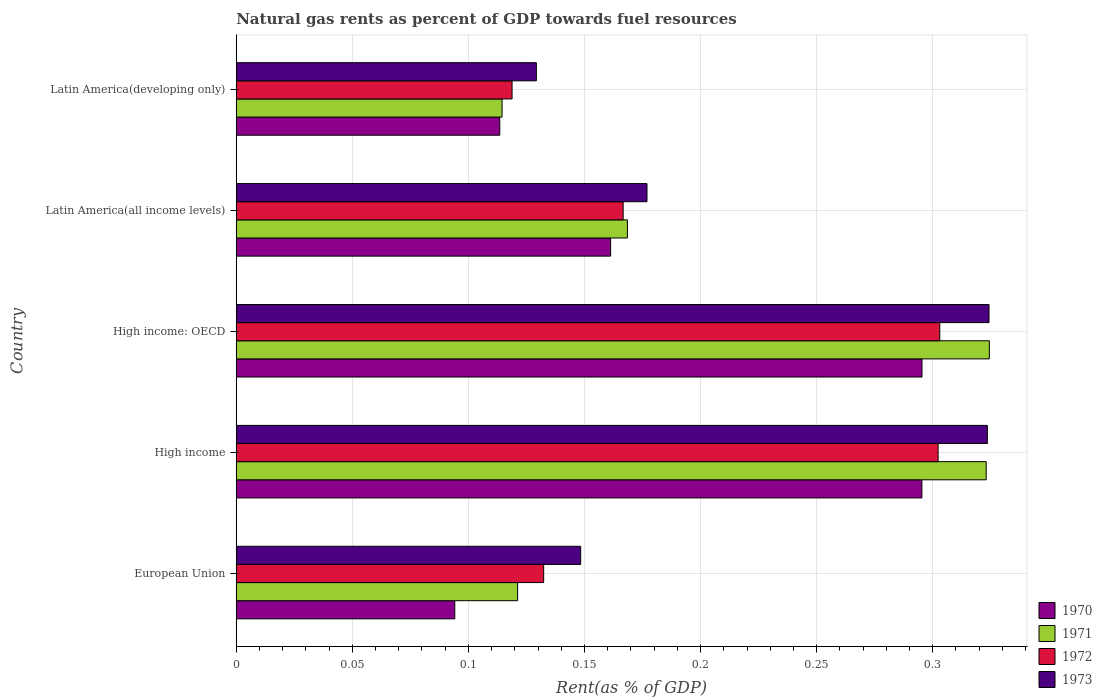How many different coloured bars are there?
Your answer should be very brief. 4. Are the number of bars per tick equal to the number of legend labels?
Keep it short and to the point. Yes. Are the number of bars on each tick of the Y-axis equal?
Your response must be concise. Yes. How many bars are there on the 4th tick from the top?
Ensure brevity in your answer.  4. What is the label of the 2nd group of bars from the top?
Your answer should be very brief. Latin America(all income levels). In how many cases, is the number of bars for a given country not equal to the number of legend labels?
Give a very brief answer. 0. What is the matural gas rent in 1971 in Latin America(developing only)?
Offer a terse response. 0.11. Across all countries, what is the maximum matural gas rent in 1970?
Keep it short and to the point. 0.3. Across all countries, what is the minimum matural gas rent in 1972?
Give a very brief answer. 0.12. In which country was the matural gas rent in 1972 maximum?
Ensure brevity in your answer.  High income: OECD. In which country was the matural gas rent in 1972 minimum?
Your response must be concise. Latin America(developing only). What is the total matural gas rent in 1971 in the graph?
Provide a succinct answer. 1.05. What is the difference between the matural gas rent in 1971 in European Union and that in High income: OECD?
Provide a succinct answer. -0.2. What is the difference between the matural gas rent in 1970 in High income and the matural gas rent in 1973 in Latin America(developing only)?
Your answer should be compact. 0.17. What is the average matural gas rent in 1971 per country?
Keep it short and to the point. 0.21. What is the difference between the matural gas rent in 1972 and matural gas rent in 1973 in European Union?
Offer a terse response. -0.02. In how many countries, is the matural gas rent in 1971 greater than 0.01 %?
Your response must be concise. 5. What is the ratio of the matural gas rent in 1971 in High income to that in High income: OECD?
Offer a very short reply. 1. Is the matural gas rent in 1973 in Latin America(all income levels) less than that in Latin America(developing only)?
Ensure brevity in your answer.  No. Is the difference between the matural gas rent in 1972 in European Union and High income greater than the difference between the matural gas rent in 1973 in European Union and High income?
Provide a succinct answer. Yes. What is the difference between the highest and the second highest matural gas rent in 1973?
Keep it short and to the point. 0. What is the difference between the highest and the lowest matural gas rent in 1973?
Offer a very short reply. 0.19. Is it the case that in every country, the sum of the matural gas rent in 1973 and matural gas rent in 1971 is greater than the matural gas rent in 1970?
Your answer should be very brief. Yes. Are all the bars in the graph horizontal?
Make the answer very short. Yes. What is the difference between two consecutive major ticks on the X-axis?
Keep it short and to the point. 0.05. Are the values on the major ticks of X-axis written in scientific E-notation?
Keep it short and to the point. No. Where does the legend appear in the graph?
Your answer should be compact. Bottom right. How many legend labels are there?
Provide a succinct answer. 4. What is the title of the graph?
Ensure brevity in your answer.  Natural gas rents as percent of GDP towards fuel resources. Does "1972" appear as one of the legend labels in the graph?
Your response must be concise. Yes. What is the label or title of the X-axis?
Your answer should be very brief. Rent(as % of GDP). What is the Rent(as % of GDP) of 1970 in European Union?
Your answer should be compact. 0.09. What is the Rent(as % of GDP) in 1971 in European Union?
Provide a succinct answer. 0.12. What is the Rent(as % of GDP) of 1972 in European Union?
Ensure brevity in your answer.  0.13. What is the Rent(as % of GDP) in 1973 in European Union?
Keep it short and to the point. 0.15. What is the Rent(as % of GDP) of 1970 in High income?
Keep it short and to the point. 0.3. What is the Rent(as % of GDP) of 1971 in High income?
Offer a terse response. 0.32. What is the Rent(as % of GDP) of 1972 in High income?
Provide a succinct answer. 0.3. What is the Rent(as % of GDP) in 1973 in High income?
Ensure brevity in your answer.  0.32. What is the Rent(as % of GDP) of 1970 in High income: OECD?
Provide a succinct answer. 0.3. What is the Rent(as % of GDP) of 1971 in High income: OECD?
Your answer should be very brief. 0.32. What is the Rent(as % of GDP) of 1972 in High income: OECD?
Keep it short and to the point. 0.3. What is the Rent(as % of GDP) of 1973 in High income: OECD?
Offer a very short reply. 0.32. What is the Rent(as % of GDP) of 1970 in Latin America(all income levels)?
Make the answer very short. 0.16. What is the Rent(as % of GDP) in 1971 in Latin America(all income levels)?
Keep it short and to the point. 0.17. What is the Rent(as % of GDP) in 1972 in Latin America(all income levels)?
Your answer should be very brief. 0.17. What is the Rent(as % of GDP) of 1973 in Latin America(all income levels)?
Your response must be concise. 0.18. What is the Rent(as % of GDP) in 1970 in Latin America(developing only)?
Offer a terse response. 0.11. What is the Rent(as % of GDP) of 1971 in Latin America(developing only)?
Give a very brief answer. 0.11. What is the Rent(as % of GDP) in 1972 in Latin America(developing only)?
Offer a terse response. 0.12. What is the Rent(as % of GDP) in 1973 in Latin America(developing only)?
Provide a succinct answer. 0.13. Across all countries, what is the maximum Rent(as % of GDP) of 1970?
Keep it short and to the point. 0.3. Across all countries, what is the maximum Rent(as % of GDP) of 1971?
Provide a short and direct response. 0.32. Across all countries, what is the maximum Rent(as % of GDP) of 1972?
Provide a succinct answer. 0.3. Across all countries, what is the maximum Rent(as % of GDP) of 1973?
Give a very brief answer. 0.32. Across all countries, what is the minimum Rent(as % of GDP) in 1970?
Your response must be concise. 0.09. Across all countries, what is the minimum Rent(as % of GDP) in 1971?
Your response must be concise. 0.11. Across all countries, what is the minimum Rent(as % of GDP) of 1972?
Provide a short and direct response. 0.12. Across all countries, what is the minimum Rent(as % of GDP) in 1973?
Provide a short and direct response. 0.13. What is the total Rent(as % of GDP) in 1970 in the graph?
Provide a succinct answer. 0.96. What is the total Rent(as % of GDP) in 1971 in the graph?
Give a very brief answer. 1.05. What is the total Rent(as % of GDP) of 1972 in the graph?
Keep it short and to the point. 1.02. What is the total Rent(as % of GDP) in 1973 in the graph?
Provide a succinct answer. 1.1. What is the difference between the Rent(as % of GDP) in 1970 in European Union and that in High income?
Offer a terse response. -0.2. What is the difference between the Rent(as % of GDP) of 1971 in European Union and that in High income?
Your answer should be compact. -0.2. What is the difference between the Rent(as % of GDP) of 1972 in European Union and that in High income?
Give a very brief answer. -0.17. What is the difference between the Rent(as % of GDP) of 1973 in European Union and that in High income?
Your answer should be very brief. -0.18. What is the difference between the Rent(as % of GDP) in 1970 in European Union and that in High income: OECD?
Your response must be concise. -0.2. What is the difference between the Rent(as % of GDP) in 1971 in European Union and that in High income: OECD?
Make the answer very short. -0.2. What is the difference between the Rent(as % of GDP) of 1972 in European Union and that in High income: OECD?
Your answer should be compact. -0.17. What is the difference between the Rent(as % of GDP) in 1973 in European Union and that in High income: OECD?
Ensure brevity in your answer.  -0.18. What is the difference between the Rent(as % of GDP) of 1970 in European Union and that in Latin America(all income levels)?
Provide a short and direct response. -0.07. What is the difference between the Rent(as % of GDP) of 1971 in European Union and that in Latin America(all income levels)?
Ensure brevity in your answer.  -0.05. What is the difference between the Rent(as % of GDP) of 1972 in European Union and that in Latin America(all income levels)?
Your response must be concise. -0.03. What is the difference between the Rent(as % of GDP) of 1973 in European Union and that in Latin America(all income levels)?
Provide a short and direct response. -0.03. What is the difference between the Rent(as % of GDP) in 1970 in European Union and that in Latin America(developing only)?
Offer a very short reply. -0.02. What is the difference between the Rent(as % of GDP) in 1971 in European Union and that in Latin America(developing only)?
Offer a very short reply. 0.01. What is the difference between the Rent(as % of GDP) in 1972 in European Union and that in Latin America(developing only)?
Give a very brief answer. 0.01. What is the difference between the Rent(as % of GDP) of 1973 in European Union and that in Latin America(developing only)?
Ensure brevity in your answer.  0.02. What is the difference between the Rent(as % of GDP) in 1970 in High income and that in High income: OECD?
Your answer should be very brief. -0. What is the difference between the Rent(as % of GDP) in 1971 in High income and that in High income: OECD?
Your response must be concise. -0. What is the difference between the Rent(as % of GDP) in 1972 in High income and that in High income: OECD?
Ensure brevity in your answer.  -0. What is the difference between the Rent(as % of GDP) in 1973 in High income and that in High income: OECD?
Keep it short and to the point. -0. What is the difference between the Rent(as % of GDP) of 1970 in High income and that in Latin America(all income levels)?
Your answer should be compact. 0.13. What is the difference between the Rent(as % of GDP) of 1971 in High income and that in Latin America(all income levels)?
Give a very brief answer. 0.15. What is the difference between the Rent(as % of GDP) in 1972 in High income and that in Latin America(all income levels)?
Your answer should be very brief. 0.14. What is the difference between the Rent(as % of GDP) of 1973 in High income and that in Latin America(all income levels)?
Provide a short and direct response. 0.15. What is the difference between the Rent(as % of GDP) of 1970 in High income and that in Latin America(developing only)?
Ensure brevity in your answer.  0.18. What is the difference between the Rent(as % of GDP) of 1971 in High income and that in Latin America(developing only)?
Keep it short and to the point. 0.21. What is the difference between the Rent(as % of GDP) of 1972 in High income and that in Latin America(developing only)?
Your answer should be compact. 0.18. What is the difference between the Rent(as % of GDP) of 1973 in High income and that in Latin America(developing only)?
Give a very brief answer. 0.19. What is the difference between the Rent(as % of GDP) of 1970 in High income: OECD and that in Latin America(all income levels)?
Offer a terse response. 0.13. What is the difference between the Rent(as % of GDP) of 1971 in High income: OECD and that in Latin America(all income levels)?
Offer a very short reply. 0.16. What is the difference between the Rent(as % of GDP) of 1972 in High income: OECD and that in Latin America(all income levels)?
Provide a succinct answer. 0.14. What is the difference between the Rent(as % of GDP) in 1973 in High income: OECD and that in Latin America(all income levels)?
Offer a very short reply. 0.15. What is the difference between the Rent(as % of GDP) in 1970 in High income: OECD and that in Latin America(developing only)?
Keep it short and to the point. 0.18. What is the difference between the Rent(as % of GDP) in 1971 in High income: OECD and that in Latin America(developing only)?
Your answer should be compact. 0.21. What is the difference between the Rent(as % of GDP) in 1972 in High income: OECD and that in Latin America(developing only)?
Provide a short and direct response. 0.18. What is the difference between the Rent(as % of GDP) in 1973 in High income: OECD and that in Latin America(developing only)?
Your answer should be compact. 0.2. What is the difference between the Rent(as % of GDP) of 1970 in Latin America(all income levels) and that in Latin America(developing only)?
Provide a succinct answer. 0.05. What is the difference between the Rent(as % of GDP) in 1971 in Latin America(all income levels) and that in Latin America(developing only)?
Make the answer very short. 0.05. What is the difference between the Rent(as % of GDP) in 1972 in Latin America(all income levels) and that in Latin America(developing only)?
Ensure brevity in your answer.  0.05. What is the difference between the Rent(as % of GDP) of 1973 in Latin America(all income levels) and that in Latin America(developing only)?
Give a very brief answer. 0.05. What is the difference between the Rent(as % of GDP) in 1970 in European Union and the Rent(as % of GDP) in 1971 in High income?
Your answer should be very brief. -0.23. What is the difference between the Rent(as % of GDP) in 1970 in European Union and the Rent(as % of GDP) in 1972 in High income?
Offer a terse response. -0.21. What is the difference between the Rent(as % of GDP) in 1970 in European Union and the Rent(as % of GDP) in 1973 in High income?
Make the answer very short. -0.23. What is the difference between the Rent(as % of GDP) in 1971 in European Union and the Rent(as % of GDP) in 1972 in High income?
Make the answer very short. -0.18. What is the difference between the Rent(as % of GDP) in 1971 in European Union and the Rent(as % of GDP) in 1973 in High income?
Offer a very short reply. -0.2. What is the difference between the Rent(as % of GDP) in 1972 in European Union and the Rent(as % of GDP) in 1973 in High income?
Ensure brevity in your answer.  -0.19. What is the difference between the Rent(as % of GDP) of 1970 in European Union and the Rent(as % of GDP) of 1971 in High income: OECD?
Your response must be concise. -0.23. What is the difference between the Rent(as % of GDP) of 1970 in European Union and the Rent(as % of GDP) of 1972 in High income: OECD?
Your answer should be very brief. -0.21. What is the difference between the Rent(as % of GDP) of 1970 in European Union and the Rent(as % of GDP) of 1973 in High income: OECD?
Your answer should be very brief. -0.23. What is the difference between the Rent(as % of GDP) of 1971 in European Union and the Rent(as % of GDP) of 1972 in High income: OECD?
Your response must be concise. -0.18. What is the difference between the Rent(as % of GDP) of 1971 in European Union and the Rent(as % of GDP) of 1973 in High income: OECD?
Give a very brief answer. -0.2. What is the difference between the Rent(as % of GDP) of 1972 in European Union and the Rent(as % of GDP) of 1973 in High income: OECD?
Offer a very short reply. -0.19. What is the difference between the Rent(as % of GDP) of 1970 in European Union and the Rent(as % of GDP) of 1971 in Latin America(all income levels)?
Make the answer very short. -0.07. What is the difference between the Rent(as % of GDP) of 1970 in European Union and the Rent(as % of GDP) of 1972 in Latin America(all income levels)?
Your answer should be very brief. -0.07. What is the difference between the Rent(as % of GDP) in 1970 in European Union and the Rent(as % of GDP) in 1973 in Latin America(all income levels)?
Ensure brevity in your answer.  -0.08. What is the difference between the Rent(as % of GDP) of 1971 in European Union and the Rent(as % of GDP) of 1972 in Latin America(all income levels)?
Give a very brief answer. -0.05. What is the difference between the Rent(as % of GDP) in 1971 in European Union and the Rent(as % of GDP) in 1973 in Latin America(all income levels)?
Your response must be concise. -0.06. What is the difference between the Rent(as % of GDP) of 1972 in European Union and the Rent(as % of GDP) of 1973 in Latin America(all income levels)?
Ensure brevity in your answer.  -0.04. What is the difference between the Rent(as % of GDP) in 1970 in European Union and the Rent(as % of GDP) in 1971 in Latin America(developing only)?
Your response must be concise. -0.02. What is the difference between the Rent(as % of GDP) of 1970 in European Union and the Rent(as % of GDP) of 1972 in Latin America(developing only)?
Your answer should be compact. -0.02. What is the difference between the Rent(as % of GDP) of 1970 in European Union and the Rent(as % of GDP) of 1973 in Latin America(developing only)?
Provide a short and direct response. -0.04. What is the difference between the Rent(as % of GDP) in 1971 in European Union and the Rent(as % of GDP) in 1972 in Latin America(developing only)?
Your answer should be very brief. 0. What is the difference between the Rent(as % of GDP) in 1971 in European Union and the Rent(as % of GDP) in 1973 in Latin America(developing only)?
Make the answer very short. -0.01. What is the difference between the Rent(as % of GDP) in 1972 in European Union and the Rent(as % of GDP) in 1973 in Latin America(developing only)?
Your answer should be very brief. 0. What is the difference between the Rent(as % of GDP) in 1970 in High income and the Rent(as % of GDP) in 1971 in High income: OECD?
Provide a short and direct response. -0.03. What is the difference between the Rent(as % of GDP) of 1970 in High income and the Rent(as % of GDP) of 1972 in High income: OECD?
Provide a short and direct response. -0.01. What is the difference between the Rent(as % of GDP) of 1970 in High income and the Rent(as % of GDP) of 1973 in High income: OECD?
Your answer should be very brief. -0.03. What is the difference between the Rent(as % of GDP) in 1971 in High income and the Rent(as % of GDP) in 1972 in High income: OECD?
Give a very brief answer. 0.02. What is the difference between the Rent(as % of GDP) of 1971 in High income and the Rent(as % of GDP) of 1973 in High income: OECD?
Make the answer very short. -0. What is the difference between the Rent(as % of GDP) of 1972 in High income and the Rent(as % of GDP) of 1973 in High income: OECD?
Offer a terse response. -0.02. What is the difference between the Rent(as % of GDP) of 1970 in High income and the Rent(as % of GDP) of 1971 in Latin America(all income levels)?
Ensure brevity in your answer.  0.13. What is the difference between the Rent(as % of GDP) in 1970 in High income and the Rent(as % of GDP) in 1972 in Latin America(all income levels)?
Your response must be concise. 0.13. What is the difference between the Rent(as % of GDP) in 1970 in High income and the Rent(as % of GDP) in 1973 in Latin America(all income levels)?
Provide a short and direct response. 0.12. What is the difference between the Rent(as % of GDP) in 1971 in High income and the Rent(as % of GDP) in 1972 in Latin America(all income levels)?
Keep it short and to the point. 0.16. What is the difference between the Rent(as % of GDP) of 1971 in High income and the Rent(as % of GDP) of 1973 in Latin America(all income levels)?
Your answer should be compact. 0.15. What is the difference between the Rent(as % of GDP) of 1972 in High income and the Rent(as % of GDP) of 1973 in Latin America(all income levels)?
Provide a succinct answer. 0.13. What is the difference between the Rent(as % of GDP) in 1970 in High income and the Rent(as % of GDP) in 1971 in Latin America(developing only)?
Your answer should be compact. 0.18. What is the difference between the Rent(as % of GDP) in 1970 in High income and the Rent(as % of GDP) in 1972 in Latin America(developing only)?
Offer a very short reply. 0.18. What is the difference between the Rent(as % of GDP) of 1970 in High income and the Rent(as % of GDP) of 1973 in Latin America(developing only)?
Offer a very short reply. 0.17. What is the difference between the Rent(as % of GDP) in 1971 in High income and the Rent(as % of GDP) in 1972 in Latin America(developing only)?
Provide a succinct answer. 0.2. What is the difference between the Rent(as % of GDP) of 1971 in High income and the Rent(as % of GDP) of 1973 in Latin America(developing only)?
Your response must be concise. 0.19. What is the difference between the Rent(as % of GDP) in 1972 in High income and the Rent(as % of GDP) in 1973 in Latin America(developing only)?
Your response must be concise. 0.17. What is the difference between the Rent(as % of GDP) in 1970 in High income: OECD and the Rent(as % of GDP) in 1971 in Latin America(all income levels)?
Keep it short and to the point. 0.13. What is the difference between the Rent(as % of GDP) of 1970 in High income: OECD and the Rent(as % of GDP) of 1972 in Latin America(all income levels)?
Make the answer very short. 0.13. What is the difference between the Rent(as % of GDP) in 1970 in High income: OECD and the Rent(as % of GDP) in 1973 in Latin America(all income levels)?
Make the answer very short. 0.12. What is the difference between the Rent(as % of GDP) of 1971 in High income: OECD and the Rent(as % of GDP) of 1972 in Latin America(all income levels)?
Ensure brevity in your answer.  0.16. What is the difference between the Rent(as % of GDP) in 1971 in High income: OECD and the Rent(as % of GDP) in 1973 in Latin America(all income levels)?
Offer a terse response. 0.15. What is the difference between the Rent(as % of GDP) of 1972 in High income: OECD and the Rent(as % of GDP) of 1973 in Latin America(all income levels)?
Provide a succinct answer. 0.13. What is the difference between the Rent(as % of GDP) of 1970 in High income: OECD and the Rent(as % of GDP) of 1971 in Latin America(developing only)?
Provide a succinct answer. 0.18. What is the difference between the Rent(as % of GDP) in 1970 in High income: OECD and the Rent(as % of GDP) in 1972 in Latin America(developing only)?
Your answer should be very brief. 0.18. What is the difference between the Rent(as % of GDP) in 1970 in High income: OECD and the Rent(as % of GDP) in 1973 in Latin America(developing only)?
Offer a very short reply. 0.17. What is the difference between the Rent(as % of GDP) of 1971 in High income: OECD and the Rent(as % of GDP) of 1972 in Latin America(developing only)?
Give a very brief answer. 0.21. What is the difference between the Rent(as % of GDP) of 1971 in High income: OECD and the Rent(as % of GDP) of 1973 in Latin America(developing only)?
Provide a short and direct response. 0.2. What is the difference between the Rent(as % of GDP) of 1972 in High income: OECD and the Rent(as % of GDP) of 1973 in Latin America(developing only)?
Ensure brevity in your answer.  0.17. What is the difference between the Rent(as % of GDP) in 1970 in Latin America(all income levels) and the Rent(as % of GDP) in 1971 in Latin America(developing only)?
Provide a short and direct response. 0.05. What is the difference between the Rent(as % of GDP) of 1970 in Latin America(all income levels) and the Rent(as % of GDP) of 1972 in Latin America(developing only)?
Keep it short and to the point. 0.04. What is the difference between the Rent(as % of GDP) of 1970 in Latin America(all income levels) and the Rent(as % of GDP) of 1973 in Latin America(developing only)?
Provide a short and direct response. 0.03. What is the difference between the Rent(as % of GDP) of 1971 in Latin America(all income levels) and the Rent(as % of GDP) of 1972 in Latin America(developing only)?
Offer a terse response. 0.05. What is the difference between the Rent(as % of GDP) in 1971 in Latin America(all income levels) and the Rent(as % of GDP) in 1973 in Latin America(developing only)?
Make the answer very short. 0.04. What is the difference between the Rent(as % of GDP) in 1972 in Latin America(all income levels) and the Rent(as % of GDP) in 1973 in Latin America(developing only)?
Keep it short and to the point. 0.04. What is the average Rent(as % of GDP) of 1970 per country?
Make the answer very short. 0.19. What is the average Rent(as % of GDP) of 1971 per country?
Keep it short and to the point. 0.21. What is the average Rent(as % of GDP) in 1972 per country?
Offer a terse response. 0.2. What is the average Rent(as % of GDP) in 1973 per country?
Provide a succinct answer. 0.22. What is the difference between the Rent(as % of GDP) in 1970 and Rent(as % of GDP) in 1971 in European Union?
Ensure brevity in your answer.  -0.03. What is the difference between the Rent(as % of GDP) of 1970 and Rent(as % of GDP) of 1972 in European Union?
Make the answer very short. -0.04. What is the difference between the Rent(as % of GDP) in 1970 and Rent(as % of GDP) in 1973 in European Union?
Keep it short and to the point. -0.05. What is the difference between the Rent(as % of GDP) in 1971 and Rent(as % of GDP) in 1972 in European Union?
Give a very brief answer. -0.01. What is the difference between the Rent(as % of GDP) of 1971 and Rent(as % of GDP) of 1973 in European Union?
Your answer should be very brief. -0.03. What is the difference between the Rent(as % of GDP) in 1972 and Rent(as % of GDP) in 1973 in European Union?
Make the answer very short. -0.02. What is the difference between the Rent(as % of GDP) of 1970 and Rent(as % of GDP) of 1971 in High income?
Give a very brief answer. -0.03. What is the difference between the Rent(as % of GDP) in 1970 and Rent(as % of GDP) in 1972 in High income?
Your answer should be very brief. -0.01. What is the difference between the Rent(as % of GDP) in 1970 and Rent(as % of GDP) in 1973 in High income?
Your answer should be very brief. -0.03. What is the difference between the Rent(as % of GDP) in 1971 and Rent(as % of GDP) in 1972 in High income?
Ensure brevity in your answer.  0.02. What is the difference between the Rent(as % of GDP) in 1971 and Rent(as % of GDP) in 1973 in High income?
Offer a terse response. -0. What is the difference between the Rent(as % of GDP) in 1972 and Rent(as % of GDP) in 1973 in High income?
Keep it short and to the point. -0.02. What is the difference between the Rent(as % of GDP) in 1970 and Rent(as % of GDP) in 1971 in High income: OECD?
Ensure brevity in your answer.  -0.03. What is the difference between the Rent(as % of GDP) of 1970 and Rent(as % of GDP) of 1972 in High income: OECD?
Your response must be concise. -0.01. What is the difference between the Rent(as % of GDP) of 1970 and Rent(as % of GDP) of 1973 in High income: OECD?
Provide a succinct answer. -0.03. What is the difference between the Rent(as % of GDP) in 1971 and Rent(as % of GDP) in 1972 in High income: OECD?
Offer a terse response. 0.02. What is the difference between the Rent(as % of GDP) in 1971 and Rent(as % of GDP) in 1973 in High income: OECD?
Offer a terse response. 0. What is the difference between the Rent(as % of GDP) in 1972 and Rent(as % of GDP) in 1973 in High income: OECD?
Ensure brevity in your answer.  -0.02. What is the difference between the Rent(as % of GDP) of 1970 and Rent(as % of GDP) of 1971 in Latin America(all income levels)?
Your response must be concise. -0.01. What is the difference between the Rent(as % of GDP) in 1970 and Rent(as % of GDP) in 1972 in Latin America(all income levels)?
Provide a short and direct response. -0.01. What is the difference between the Rent(as % of GDP) in 1970 and Rent(as % of GDP) in 1973 in Latin America(all income levels)?
Your response must be concise. -0.02. What is the difference between the Rent(as % of GDP) in 1971 and Rent(as % of GDP) in 1972 in Latin America(all income levels)?
Keep it short and to the point. 0. What is the difference between the Rent(as % of GDP) of 1971 and Rent(as % of GDP) of 1973 in Latin America(all income levels)?
Offer a terse response. -0.01. What is the difference between the Rent(as % of GDP) in 1972 and Rent(as % of GDP) in 1973 in Latin America(all income levels)?
Your answer should be compact. -0.01. What is the difference between the Rent(as % of GDP) in 1970 and Rent(as % of GDP) in 1971 in Latin America(developing only)?
Keep it short and to the point. -0. What is the difference between the Rent(as % of GDP) in 1970 and Rent(as % of GDP) in 1972 in Latin America(developing only)?
Provide a short and direct response. -0.01. What is the difference between the Rent(as % of GDP) of 1970 and Rent(as % of GDP) of 1973 in Latin America(developing only)?
Your response must be concise. -0.02. What is the difference between the Rent(as % of GDP) in 1971 and Rent(as % of GDP) in 1972 in Latin America(developing only)?
Your answer should be very brief. -0. What is the difference between the Rent(as % of GDP) in 1971 and Rent(as % of GDP) in 1973 in Latin America(developing only)?
Ensure brevity in your answer.  -0.01. What is the difference between the Rent(as % of GDP) of 1972 and Rent(as % of GDP) of 1973 in Latin America(developing only)?
Your answer should be very brief. -0.01. What is the ratio of the Rent(as % of GDP) in 1970 in European Union to that in High income?
Provide a succinct answer. 0.32. What is the ratio of the Rent(as % of GDP) of 1971 in European Union to that in High income?
Ensure brevity in your answer.  0.38. What is the ratio of the Rent(as % of GDP) in 1972 in European Union to that in High income?
Give a very brief answer. 0.44. What is the ratio of the Rent(as % of GDP) of 1973 in European Union to that in High income?
Offer a terse response. 0.46. What is the ratio of the Rent(as % of GDP) of 1970 in European Union to that in High income: OECD?
Keep it short and to the point. 0.32. What is the ratio of the Rent(as % of GDP) in 1971 in European Union to that in High income: OECD?
Make the answer very short. 0.37. What is the ratio of the Rent(as % of GDP) of 1972 in European Union to that in High income: OECD?
Make the answer very short. 0.44. What is the ratio of the Rent(as % of GDP) in 1973 in European Union to that in High income: OECD?
Give a very brief answer. 0.46. What is the ratio of the Rent(as % of GDP) in 1970 in European Union to that in Latin America(all income levels)?
Give a very brief answer. 0.58. What is the ratio of the Rent(as % of GDP) in 1971 in European Union to that in Latin America(all income levels)?
Your answer should be compact. 0.72. What is the ratio of the Rent(as % of GDP) in 1972 in European Union to that in Latin America(all income levels)?
Provide a succinct answer. 0.79. What is the ratio of the Rent(as % of GDP) of 1973 in European Union to that in Latin America(all income levels)?
Offer a terse response. 0.84. What is the ratio of the Rent(as % of GDP) in 1970 in European Union to that in Latin America(developing only)?
Provide a succinct answer. 0.83. What is the ratio of the Rent(as % of GDP) of 1971 in European Union to that in Latin America(developing only)?
Keep it short and to the point. 1.06. What is the ratio of the Rent(as % of GDP) of 1972 in European Union to that in Latin America(developing only)?
Offer a very short reply. 1.11. What is the ratio of the Rent(as % of GDP) of 1973 in European Union to that in Latin America(developing only)?
Your answer should be compact. 1.15. What is the ratio of the Rent(as % of GDP) of 1970 in High income to that in High income: OECD?
Offer a very short reply. 1. What is the ratio of the Rent(as % of GDP) in 1970 in High income to that in Latin America(all income levels)?
Keep it short and to the point. 1.83. What is the ratio of the Rent(as % of GDP) of 1971 in High income to that in Latin America(all income levels)?
Ensure brevity in your answer.  1.92. What is the ratio of the Rent(as % of GDP) in 1972 in High income to that in Latin America(all income levels)?
Offer a terse response. 1.81. What is the ratio of the Rent(as % of GDP) of 1973 in High income to that in Latin America(all income levels)?
Provide a short and direct response. 1.83. What is the ratio of the Rent(as % of GDP) in 1970 in High income to that in Latin America(developing only)?
Offer a terse response. 2.6. What is the ratio of the Rent(as % of GDP) in 1971 in High income to that in Latin America(developing only)?
Provide a short and direct response. 2.82. What is the ratio of the Rent(as % of GDP) in 1972 in High income to that in Latin America(developing only)?
Keep it short and to the point. 2.54. What is the ratio of the Rent(as % of GDP) of 1973 in High income to that in Latin America(developing only)?
Offer a terse response. 2.5. What is the ratio of the Rent(as % of GDP) of 1970 in High income: OECD to that in Latin America(all income levels)?
Make the answer very short. 1.83. What is the ratio of the Rent(as % of GDP) in 1971 in High income: OECD to that in Latin America(all income levels)?
Keep it short and to the point. 1.93. What is the ratio of the Rent(as % of GDP) of 1972 in High income: OECD to that in Latin America(all income levels)?
Offer a terse response. 1.82. What is the ratio of the Rent(as % of GDP) in 1973 in High income: OECD to that in Latin America(all income levels)?
Keep it short and to the point. 1.83. What is the ratio of the Rent(as % of GDP) in 1970 in High income: OECD to that in Latin America(developing only)?
Make the answer very short. 2.6. What is the ratio of the Rent(as % of GDP) of 1971 in High income: OECD to that in Latin America(developing only)?
Give a very brief answer. 2.83. What is the ratio of the Rent(as % of GDP) in 1972 in High income: OECD to that in Latin America(developing only)?
Provide a short and direct response. 2.55. What is the ratio of the Rent(as % of GDP) in 1973 in High income: OECD to that in Latin America(developing only)?
Your response must be concise. 2.51. What is the ratio of the Rent(as % of GDP) of 1970 in Latin America(all income levels) to that in Latin America(developing only)?
Keep it short and to the point. 1.42. What is the ratio of the Rent(as % of GDP) of 1971 in Latin America(all income levels) to that in Latin America(developing only)?
Make the answer very short. 1.47. What is the ratio of the Rent(as % of GDP) in 1972 in Latin America(all income levels) to that in Latin America(developing only)?
Your response must be concise. 1.4. What is the ratio of the Rent(as % of GDP) in 1973 in Latin America(all income levels) to that in Latin America(developing only)?
Ensure brevity in your answer.  1.37. What is the difference between the highest and the second highest Rent(as % of GDP) of 1970?
Keep it short and to the point. 0. What is the difference between the highest and the second highest Rent(as % of GDP) in 1971?
Provide a short and direct response. 0. What is the difference between the highest and the second highest Rent(as % of GDP) of 1972?
Give a very brief answer. 0. What is the difference between the highest and the second highest Rent(as % of GDP) in 1973?
Provide a succinct answer. 0. What is the difference between the highest and the lowest Rent(as % of GDP) in 1970?
Ensure brevity in your answer.  0.2. What is the difference between the highest and the lowest Rent(as % of GDP) in 1971?
Offer a very short reply. 0.21. What is the difference between the highest and the lowest Rent(as % of GDP) of 1972?
Give a very brief answer. 0.18. What is the difference between the highest and the lowest Rent(as % of GDP) in 1973?
Give a very brief answer. 0.2. 